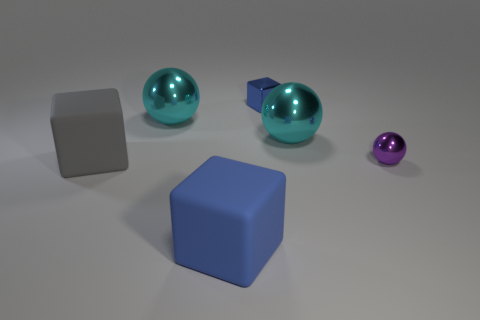Do the shadows give us any information about the light source? Indeed, the shadows are cast to the lower right of the objects, suggesting a light source above and to the left of the scene. The sharpness of the shadows indicates that the light is fairly direct, which could imply a single, perhaps somewhat distant light source. 